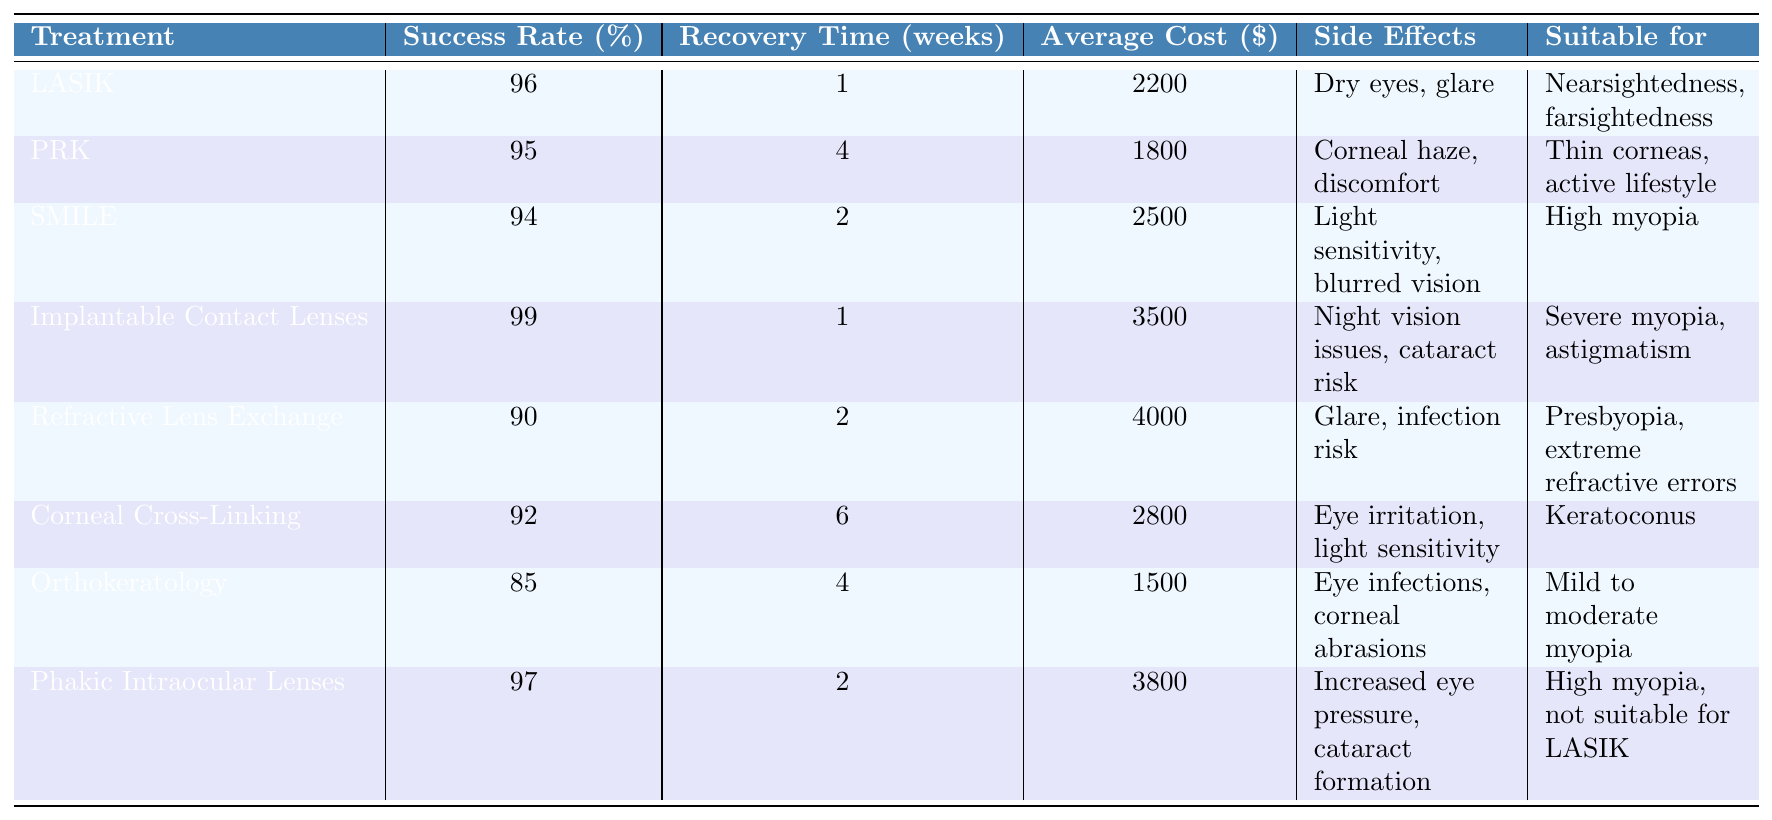What is the success rate for Implantable Contact Lenses? The success rate for Implantable Contact Lenses is listed directly in the table under the "Success Rate (%)" column.
Answer: 99% Which treatment has the highest average cost? The table provides the average cost for each treatment. Implantable Contact Lenses, with a cost of $3500, has the highest average cost.
Answer: Implantable Contact Lenses How long does recovery take for PRK? The recovery time for PRK is indicated in the "Recovery Time (weeks)" column of the table. It states that recovery takes 4 weeks.
Answer: 4 weeks Is Orthokeratology suitable for severe myopia? The table specifies that Orthokeratology is suitable for mild to moderate myopia. Since severe myopia is not included, it is not suitable for this condition.
Answer: No Calculate the average success rate of LASIK and phakic intraocular lenses. The success rates for LASIK and Phakic Intraocular Lenses are 96% and 97%, respectively. The average is calculated as (96 + 97) / 2 = 96.5.
Answer: 96.5% What side effect is common to both LASIK and SMILE? The side effects listed for LASIK are "Dry eyes, glare" and for SMILE are "Light sensitivity, blurred vision." Since there are no common side effects mentioned for both treatments, the answer is none.
Answer: None Which treatment has the shortest recovery time and what is it? By checking the "Recovery Time (weeks)" column, LASIK and Implantable Contact Lenses both have the shortest recovery time of 1 week.
Answer: 1 week Is the average cost of Corneal Cross-Linking less than $3000? The average cost for Corneal Cross-Linking is listed as $2800. Since this is less than $3000, the answer is yes.
Answer: Yes What percentage difference in success rates exist between Refractive Lens Exchange and Corneal Cross-Linking? The success rate for Refractive Lens Exchange is 90% and for Corneal Cross-Linking is 92%. The difference is calculated as 92 - 90 = 2%.
Answer: 2% Are the side effects of Implantable Contact Lenses more severe than those of Orthokeratology? The side effects for Implantable Contact Lenses include "Night vision issues, cataract risk," while Orthokeratology has "Eye infections, corneal abrasions." Both have potential risks, but since cataract risk is generally viewed as more severe, the answer leans towards yes.
Answer: Yes 